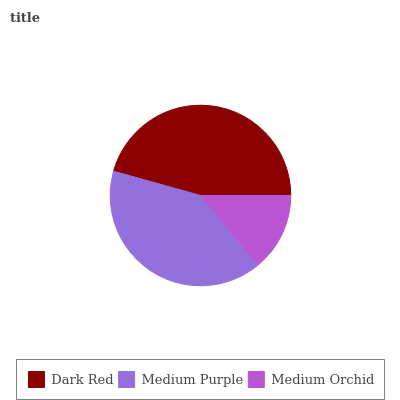Is Medium Orchid the minimum?
Answer yes or no. Yes. Is Dark Red the maximum?
Answer yes or no. Yes. Is Medium Purple the minimum?
Answer yes or no. No. Is Medium Purple the maximum?
Answer yes or no. No. Is Dark Red greater than Medium Purple?
Answer yes or no. Yes. Is Medium Purple less than Dark Red?
Answer yes or no. Yes. Is Medium Purple greater than Dark Red?
Answer yes or no. No. Is Dark Red less than Medium Purple?
Answer yes or no. No. Is Medium Purple the high median?
Answer yes or no. Yes. Is Medium Purple the low median?
Answer yes or no. Yes. Is Medium Orchid the high median?
Answer yes or no. No. Is Dark Red the low median?
Answer yes or no. No. 